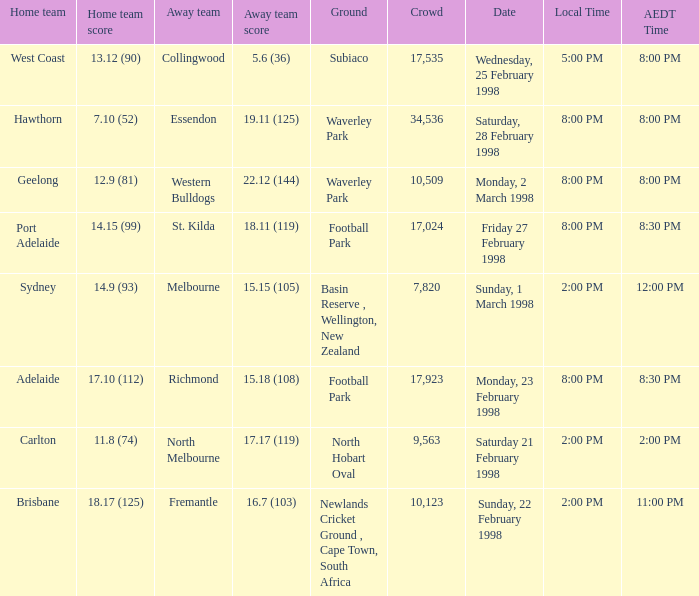Which Home team is on Wednesday, 25 february 1998? West Coast. 